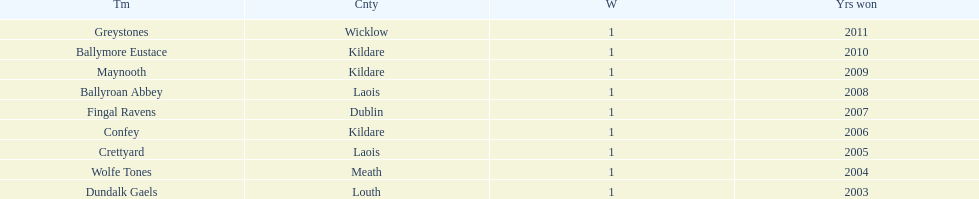After ballymore eustace, which team claimed victory? Greystones. 